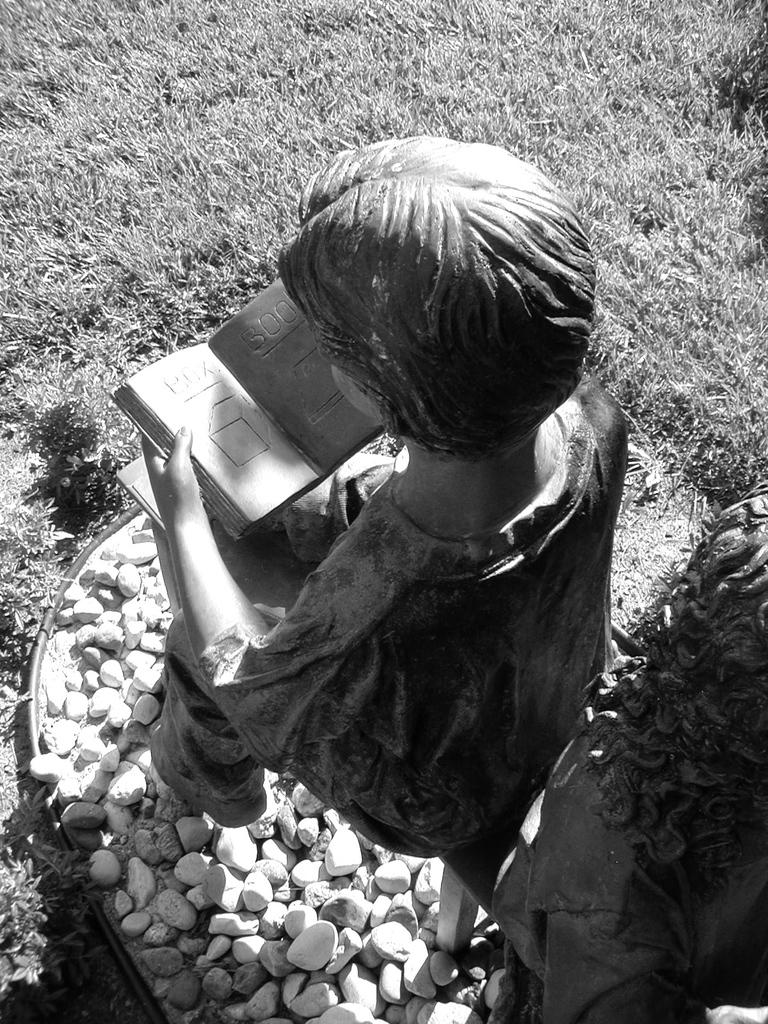What is the color scheme of the image? The image is black and white. What type of vegetation can be seen at the top of the image? There is grass at the top of the image. What is the main subject in the middle of the image? There is a statue in the middle of the image. What type of material is present at the bottom of the image? There are stones at the bottom of the image. Where can the honey be found in the image? There is no honey present in the image. What type of plantation is visible in the image? There is no plantation visible in the image. 